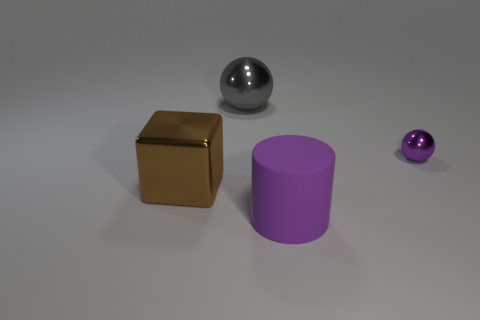Add 4 large blue balls. How many objects exist? 8 Add 4 big cubes. How many big cubes are left? 5 Add 4 rubber balls. How many rubber balls exist? 4 Subtract 0 red cylinders. How many objects are left? 4 Subtract all blocks. How many objects are left? 3 Subtract all purple shiny things. Subtract all large cyan rubber cylinders. How many objects are left? 3 